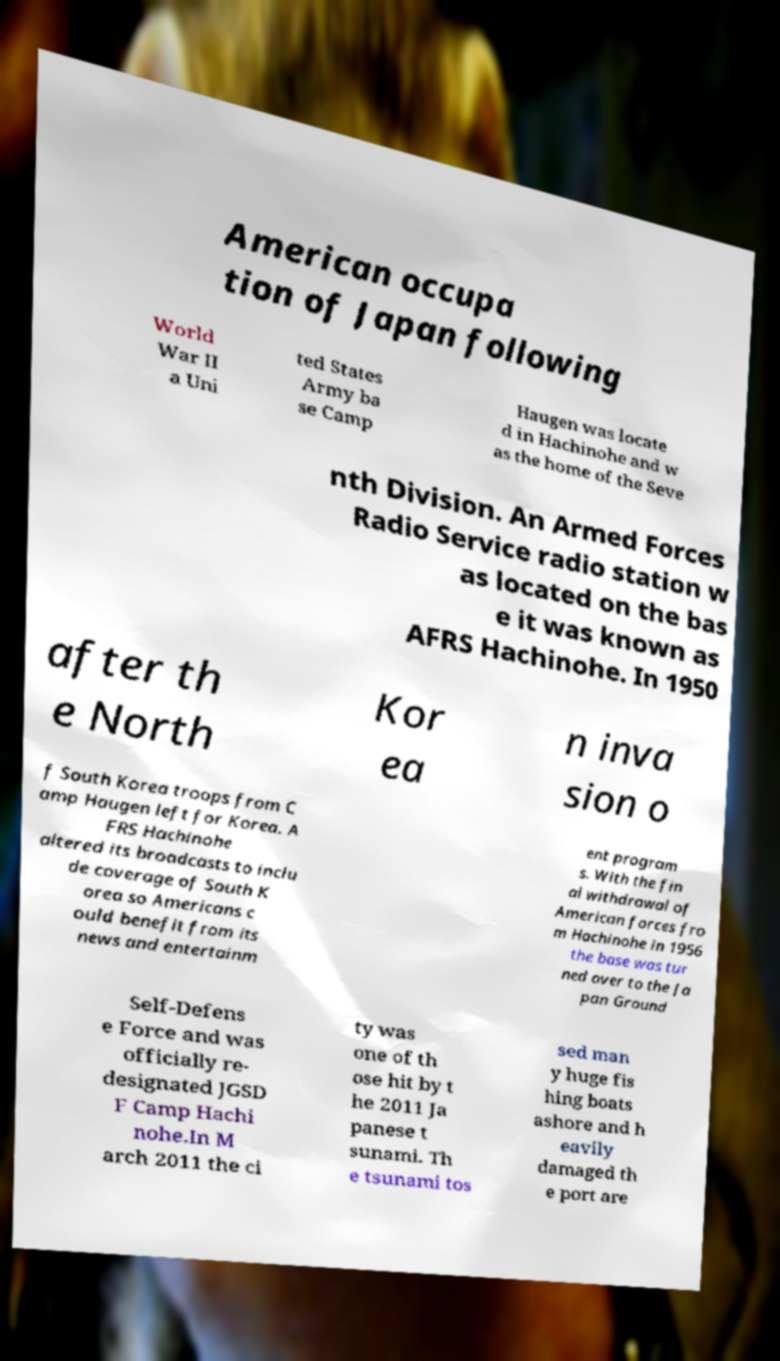I need the written content from this picture converted into text. Can you do that? American occupa tion of Japan following World War II a Uni ted States Army ba se Camp Haugen was locate d in Hachinohe and w as the home of the Seve nth Division. An Armed Forces Radio Service radio station w as located on the bas e it was known as AFRS Hachinohe. In 1950 after th e North Kor ea n inva sion o f South Korea troops from C amp Haugen left for Korea. A FRS Hachinohe altered its broadcasts to inclu de coverage of South K orea so Americans c ould benefit from its news and entertainm ent program s. With the fin al withdrawal of American forces fro m Hachinohe in 1956 the base was tur ned over to the Ja pan Ground Self-Defens e Force and was officially re- designated JGSD F Camp Hachi nohe.In M arch 2011 the ci ty was one of th ose hit by t he 2011 Ja panese t sunami. Th e tsunami tos sed man y huge fis hing boats ashore and h eavily damaged th e port are 